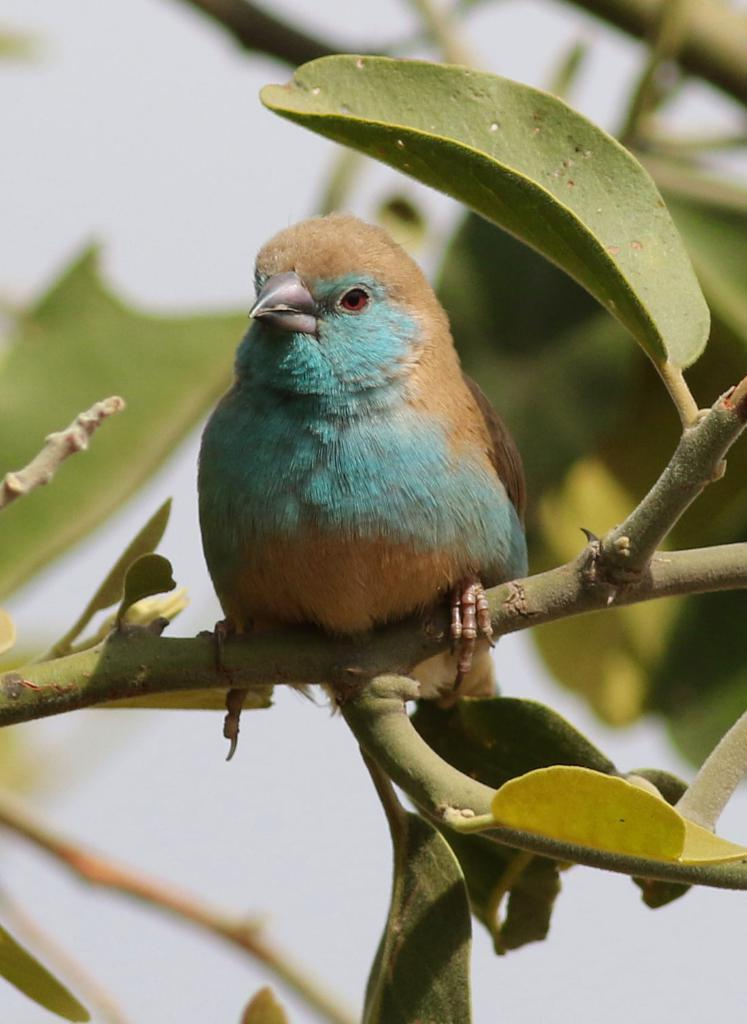What type of animal can be seen in the image? There is a bird in the image. Where is the bird located? The bird is on a plant. Can you describe the background of the image? The background of the image is blurred. What type of wound can be seen on the bird in the image? There is no wound visible on the bird in the image. Can you hear the bird whistling in the image? The image is silent, and there is no indication of the bird whistling. 